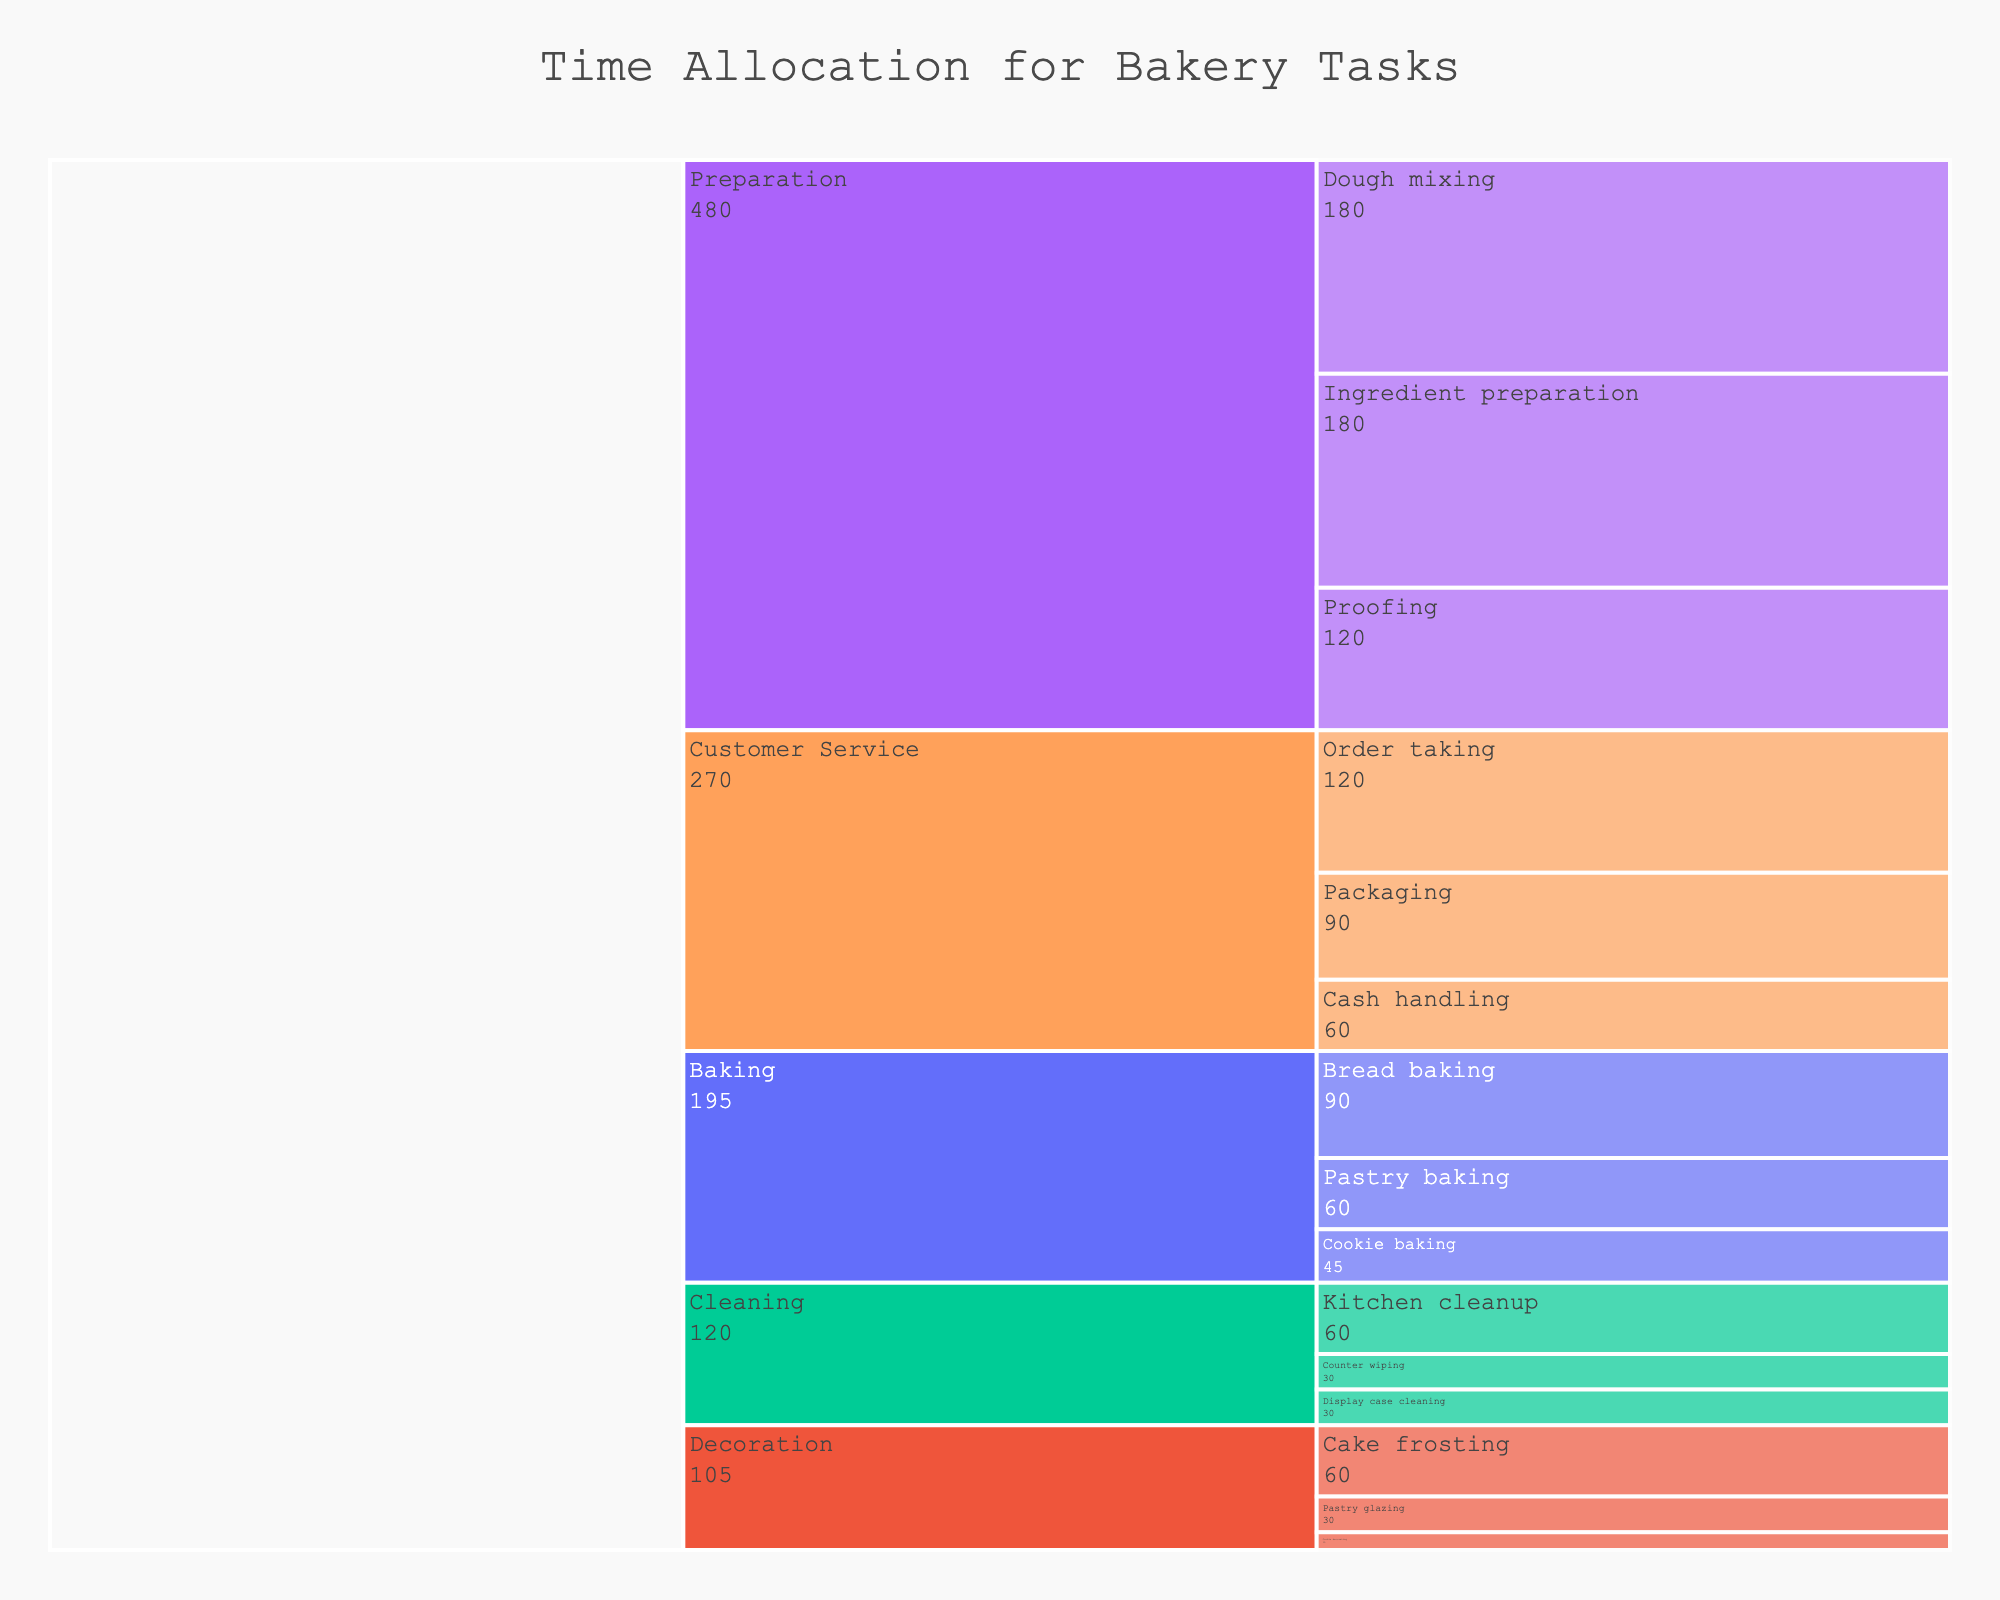What is the task that takes the longest time? Looking at the icicle chart, the task with the largest segment will represent the task taking the most time. "Preparation" has the longest duration with a sum of its subtasks equating to 480 minutes (180+180+120).
Answer: Preparation How much total time is spent on Customer Service tasks? By adding up all the times for Customer Service subtasks (120 minutes for Order taking, 90 minutes for Packaging, and 60 minutes for Cash handling), we can determine the total time spent on Customer Service. 120 + 90 + 60 = 270 minutes.
Answer: 270 minutes Which task has the shortest duration? The task with the smallest visual segment will be the one with the shortest duration. "Cleaning" has the smallest cumulative time with a total of 120 minutes (60+30+30).
Answer: Cleaning What is the difference in time spent on Baking and Decoration tasks? First, sum the times for Baking subtasks (90+60+45 = 195 minutes) and for Decoration subtasks (60+30+15 = 105 minutes). Then, subtract the total time spent on Decoration from the total time spent on Baking. 195 - 105 = 90 minutes.
Answer: 90 minutes Which subtask under Baking takes the least time? Within the Baking task, each subtask duration can be visualized. "Cookie baking" takes the least time with 45 minutes.
Answer: Cookie baking How many minutes are spent on non-baking-related tasks? Sum the total times of all tasks except for Baking. Preparation (480 minutes) + Decoration (105 minutes) + Customer Service (270 minutes) + Cleaning (120 minutes) = 975 minutes.
Answer: 975 minutes Compare the time spent on Dough mixing and Cookie decorating. Which one takes more time and by how much? Dough mixing takes 180 minutes, and Cookie decorating takes 15 minutes. Subtract the time for Cookie decorating from the time for Dough mixing to find the difference. 180 - 15 = 165 minutes.
Answer: Dough mixing by 165 minutes How much time is spent on ingredient preparation relative to the total time of Preparation tasks? The total time for Preparation tasks is 480 minutes. Ingredient preparation takes 180 minutes. Divide the time for ingredient preparation by the total time for Preparation tasks to find the proportion. 180/480 = 0.375, which is 37.5%.
Answer: 37.5% Which subtask under Customer Service has the highest time allocation? Within the Customer Service task, visualize the subtask with the largest segment. "Order taking" has the highest time allocation with 120 minutes.
Answer: Order taking What is the percentage time allocation of Kitchen cleanup compared to the entire Cleaning task? Cleaning task total time is 120 minutes, and Kitchen cleanup is 60 minutes. Divide Kitchen cleanup time by the total Cleaning time and multiply by 100 for percentage. (60/120) * 100 = 50%.
Answer: 50% 